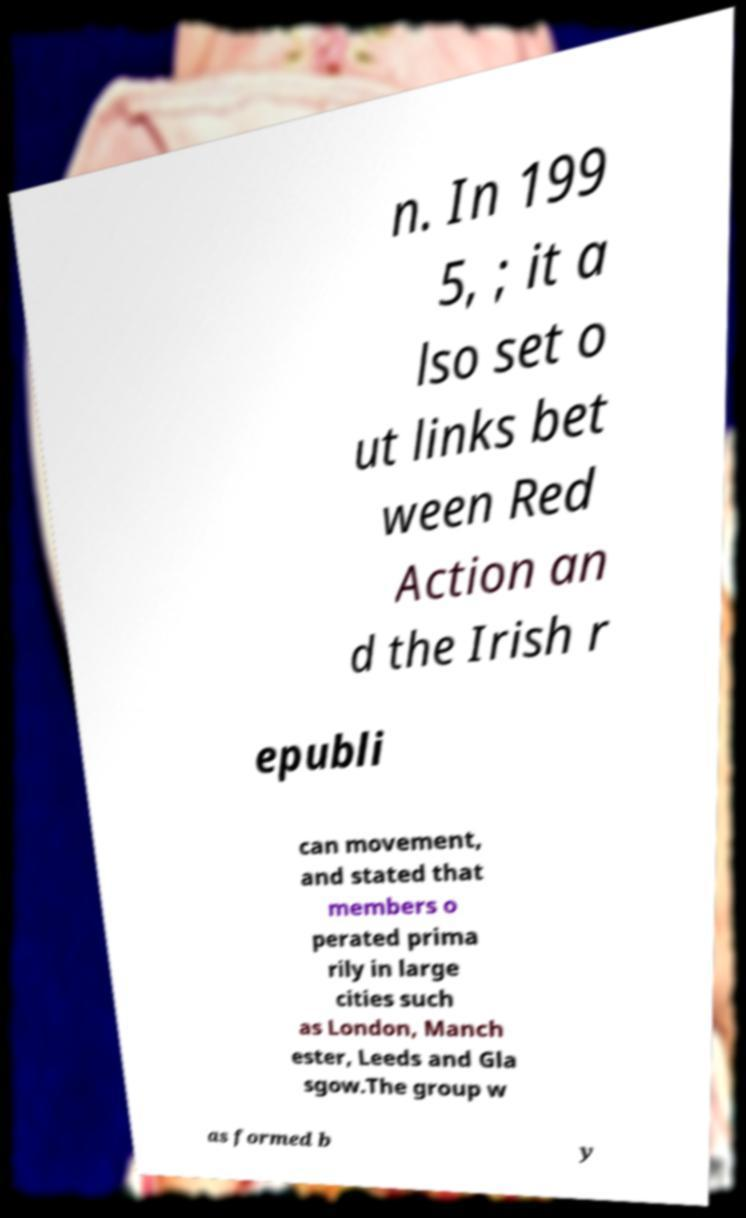Please identify and transcribe the text found in this image. n. In 199 5, ; it a lso set o ut links bet ween Red Action an d the Irish r epubli can movement, and stated that members o perated prima rily in large cities such as London, Manch ester, Leeds and Gla sgow.The group w as formed b y 